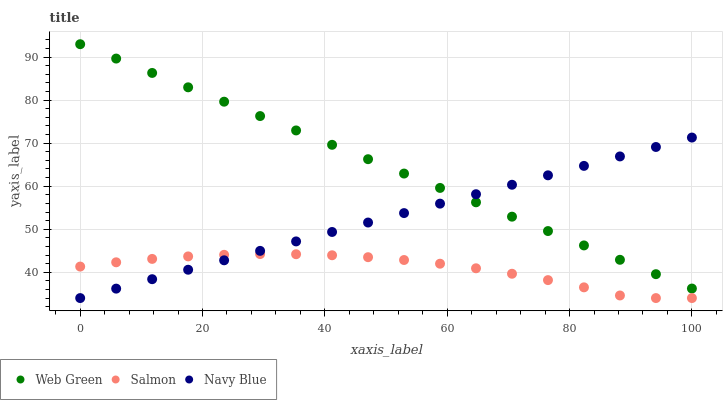Does Salmon have the minimum area under the curve?
Answer yes or no. Yes. Does Web Green have the maximum area under the curve?
Answer yes or no. Yes. Does Web Green have the minimum area under the curve?
Answer yes or no. No. Does Salmon have the maximum area under the curve?
Answer yes or no. No. Is Web Green the smoothest?
Answer yes or no. Yes. Is Salmon the roughest?
Answer yes or no. Yes. Is Salmon the smoothest?
Answer yes or no. No. Is Web Green the roughest?
Answer yes or no. No. Does Navy Blue have the lowest value?
Answer yes or no. Yes. Does Web Green have the lowest value?
Answer yes or no. No. Does Web Green have the highest value?
Answer yes or no. Yes. Does Salmon have the highest value?
Answer yes or no. No. Is Salmon less than Web Green?
Answer yes or no. Yes. Is Web Green greater than Salmon?
Answer yes or no. Yes. Does Navy Blue intersect Salmon?
Answer yes or no. Yes. Is Navy Blue less than Salmon?
Answer yes or no. No. Is Navy Blue greater than Salmon?
Answer yes or no. No. Does Salmon intersect Web Green?
Answer yes or no. No. 